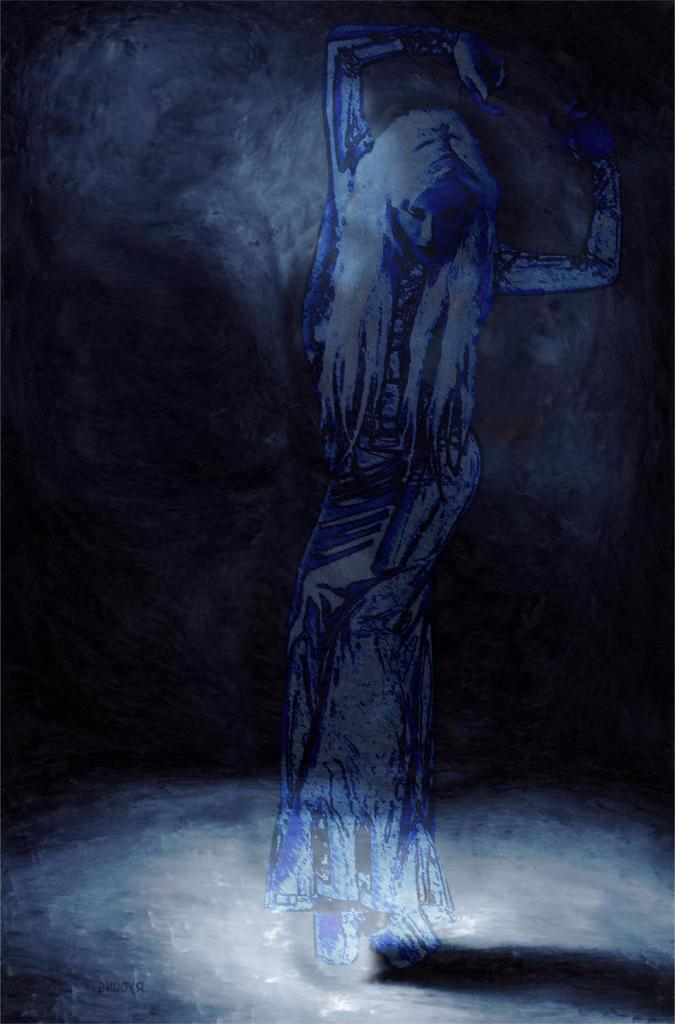What is the main subject of the image? There is a painting in the image. What is happening in the painting? The painting depicts a person standing on a surface. What can be observed about the background of the painting? The background of the painting is dark in color. What type of net is being used by the person in the painting? There is no net present in the painting; it depicts a person standing on a surface with a dark background. 